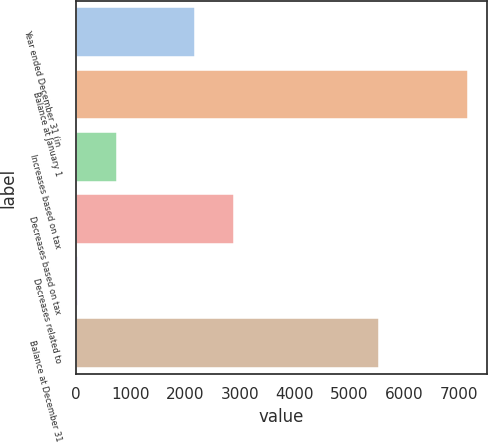Convert chart. <chart><loc_0><loc_0><loc_500><loc_500><bar_chart><fcel>Year ended December 31 (in<fcel>Balance at January 1<fcel>Increases based on tax<fcel>Decreases based on tax<fcel>Decreases related to<fcel>Balance at December 31<nl><fcel>2184.5<fcel>7158<fcel>763.5<fcel>2895<fcel>53<fcel>5535<nl></chart> 